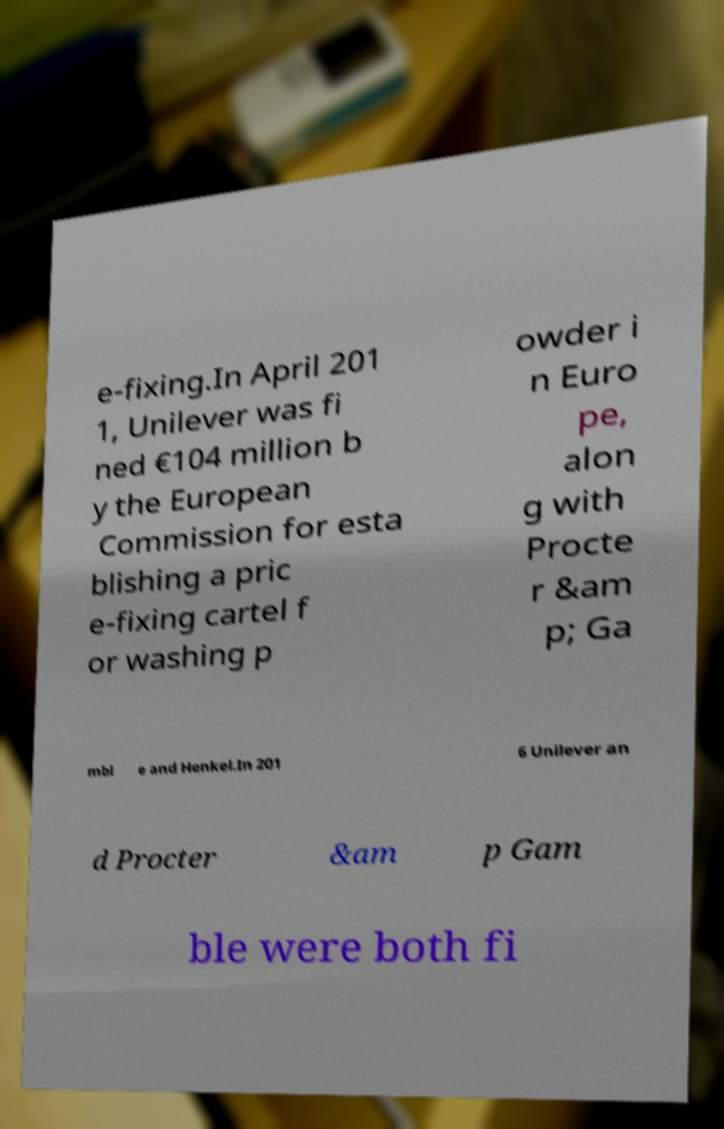For documentation purposes, I need the text within this image transcribed. Could you provide that? e-fixing.In April 201 1, Unilever was fi ned €104 million b y the European Commission for esta blishing a pric e-fixing cartel f or washing p owder i n Euro pe, alon g with Procte r &am p; Ga mbl e and Henkel.In 201 6 Unilever an d Procter &am p Gam ble were both fi 